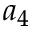Convert formula to latex. <formula><loc_0><loc_0><loc_500><loc_500>a _ { 4 }</formula> 